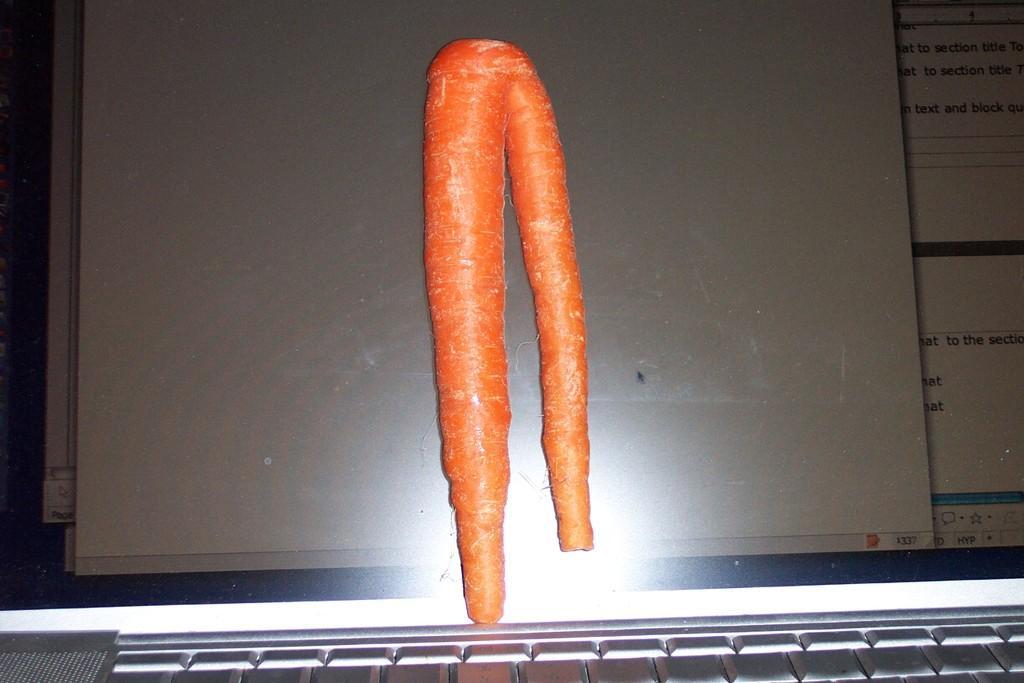Can you describe this image briefly? In this image it looks like a laptop. And we can see a carrot on the screen. 